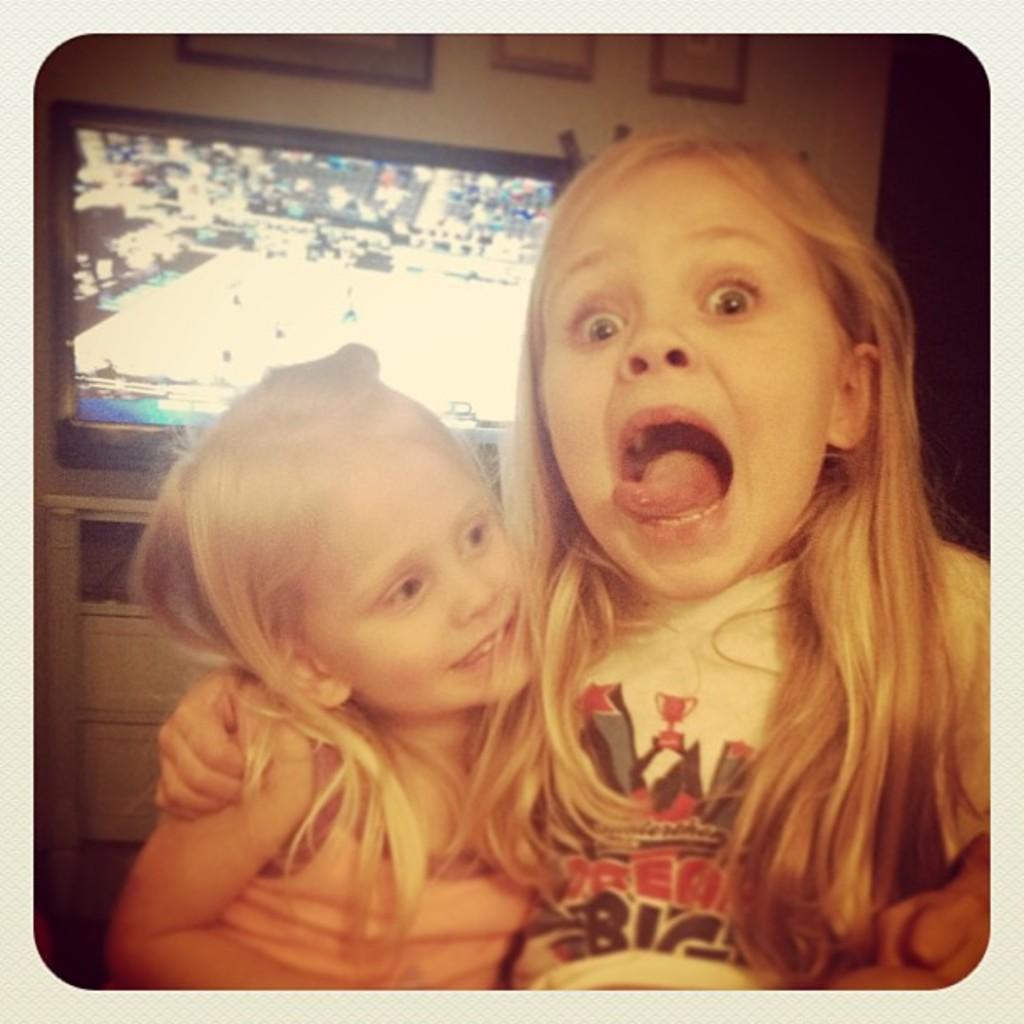Please provide a concise description of this image. In this image there are two girls. The girl to the right has wide opened her mouth. Behind them there is a television on the cupboard. Behind the television there is a wall. There are picture frames on the wall. 